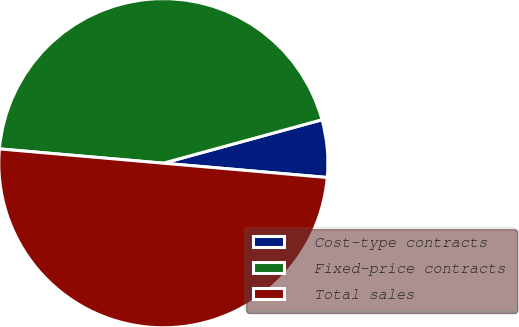<chart> <loc_0><loc_0><loc_500><loc_500><pie_chart><fcel>Cost-type contracts<fcel>Fixed-price contracts<fcel>Total sales<nl><fcel>5.64%<fcel>44.36%<fcel>50.0%<nl></chart> 